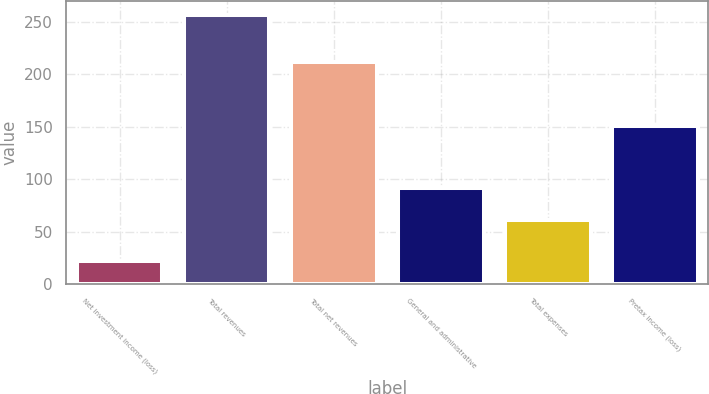Convert chart to OTSL. <chart><loc_0><loc_0><loc_500><loc_500><bar_chart><fcel>Net investment income (loss)<fcel>Total revenues<fcel>Total net revenues<fcel>General and administrative<fcel>Total expenses<fcel>Pretax income (loss)<nl><fcel>22<fcel>257<fcel>212<fcel>92<fcel>61<fcel>151<nl></chart> 